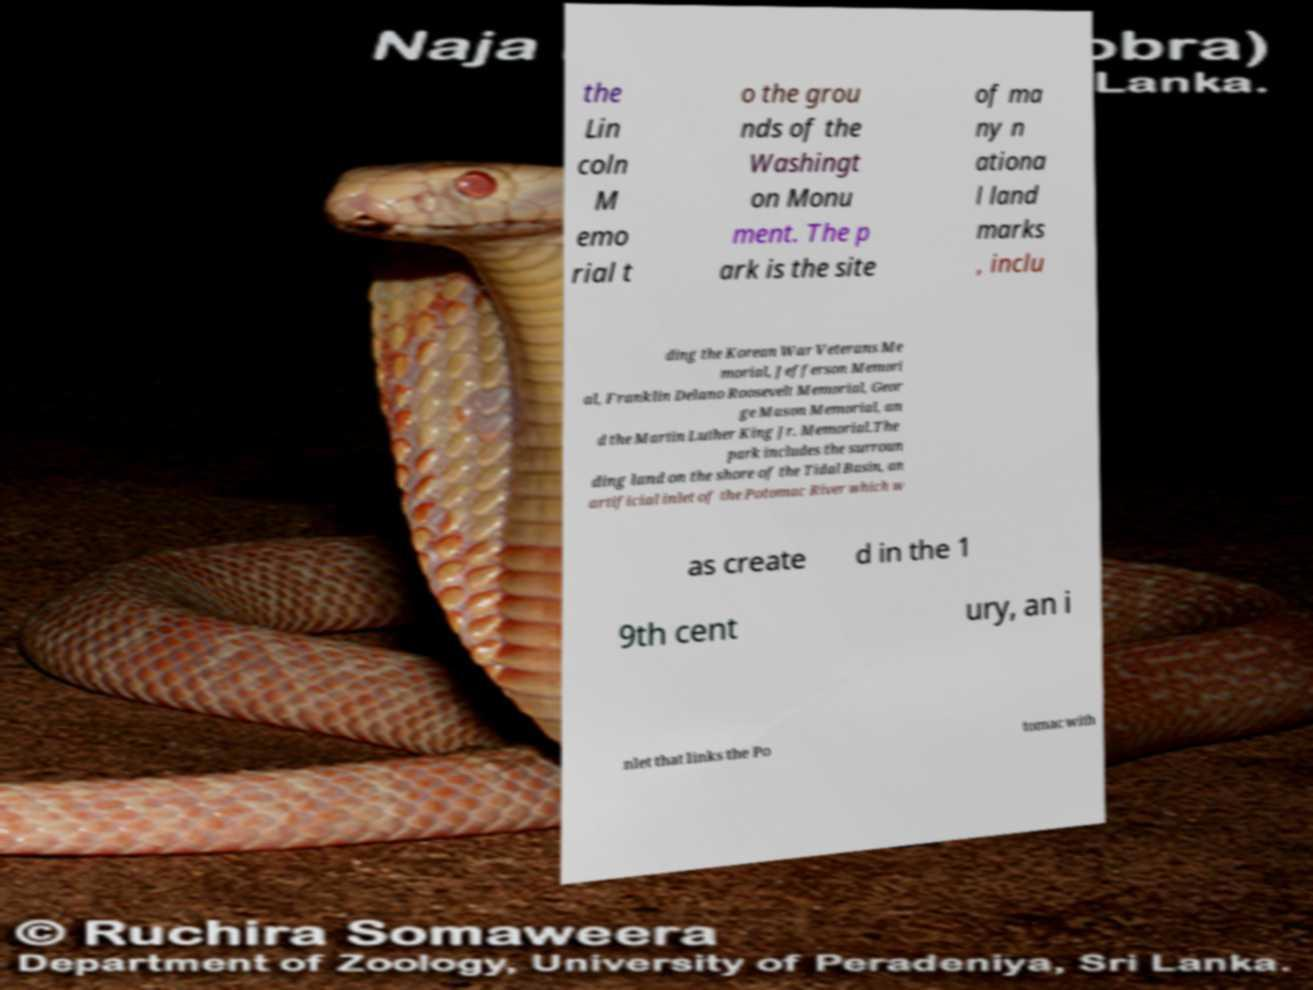I need the written content from this picture converted into text. Can you do that? the Lin coln M emo rial t o the grou nds of the Washingt on Monu ment. The p ark is the site of ma ny n ationa l land marks , inclu ding the Korean War Veterans Me morial, Jefferson Memori al, Franklin Delano Roosevelt Memorial, Geor ge Mason Memorial, an d the Martin Luther King Jr. Memorial.The park includes the surroun ding land on the shore of the Tidal Basin, an artificial inlet of the Potomac River which w as create d in the 1 9th cent ury, an i nlet that links the Po tomac with 